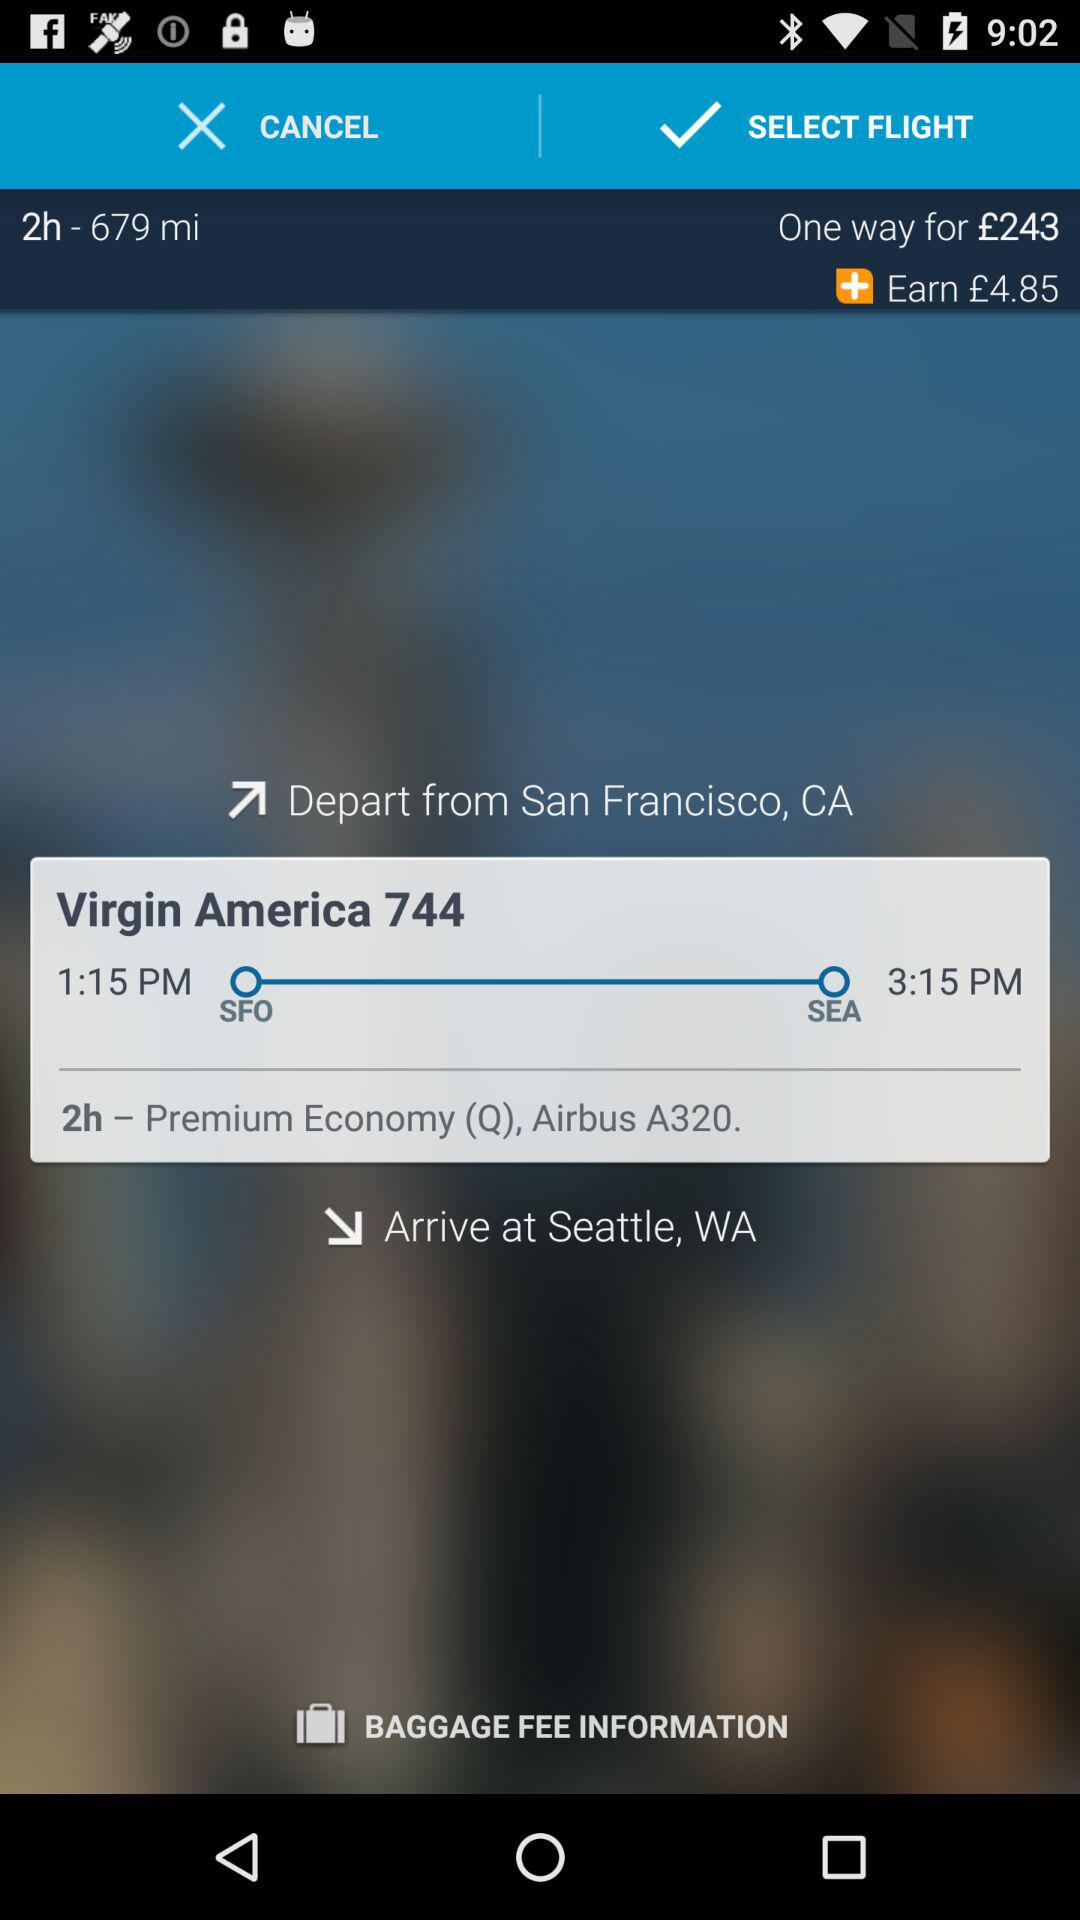How much can we earn? You can earn £4.85. 